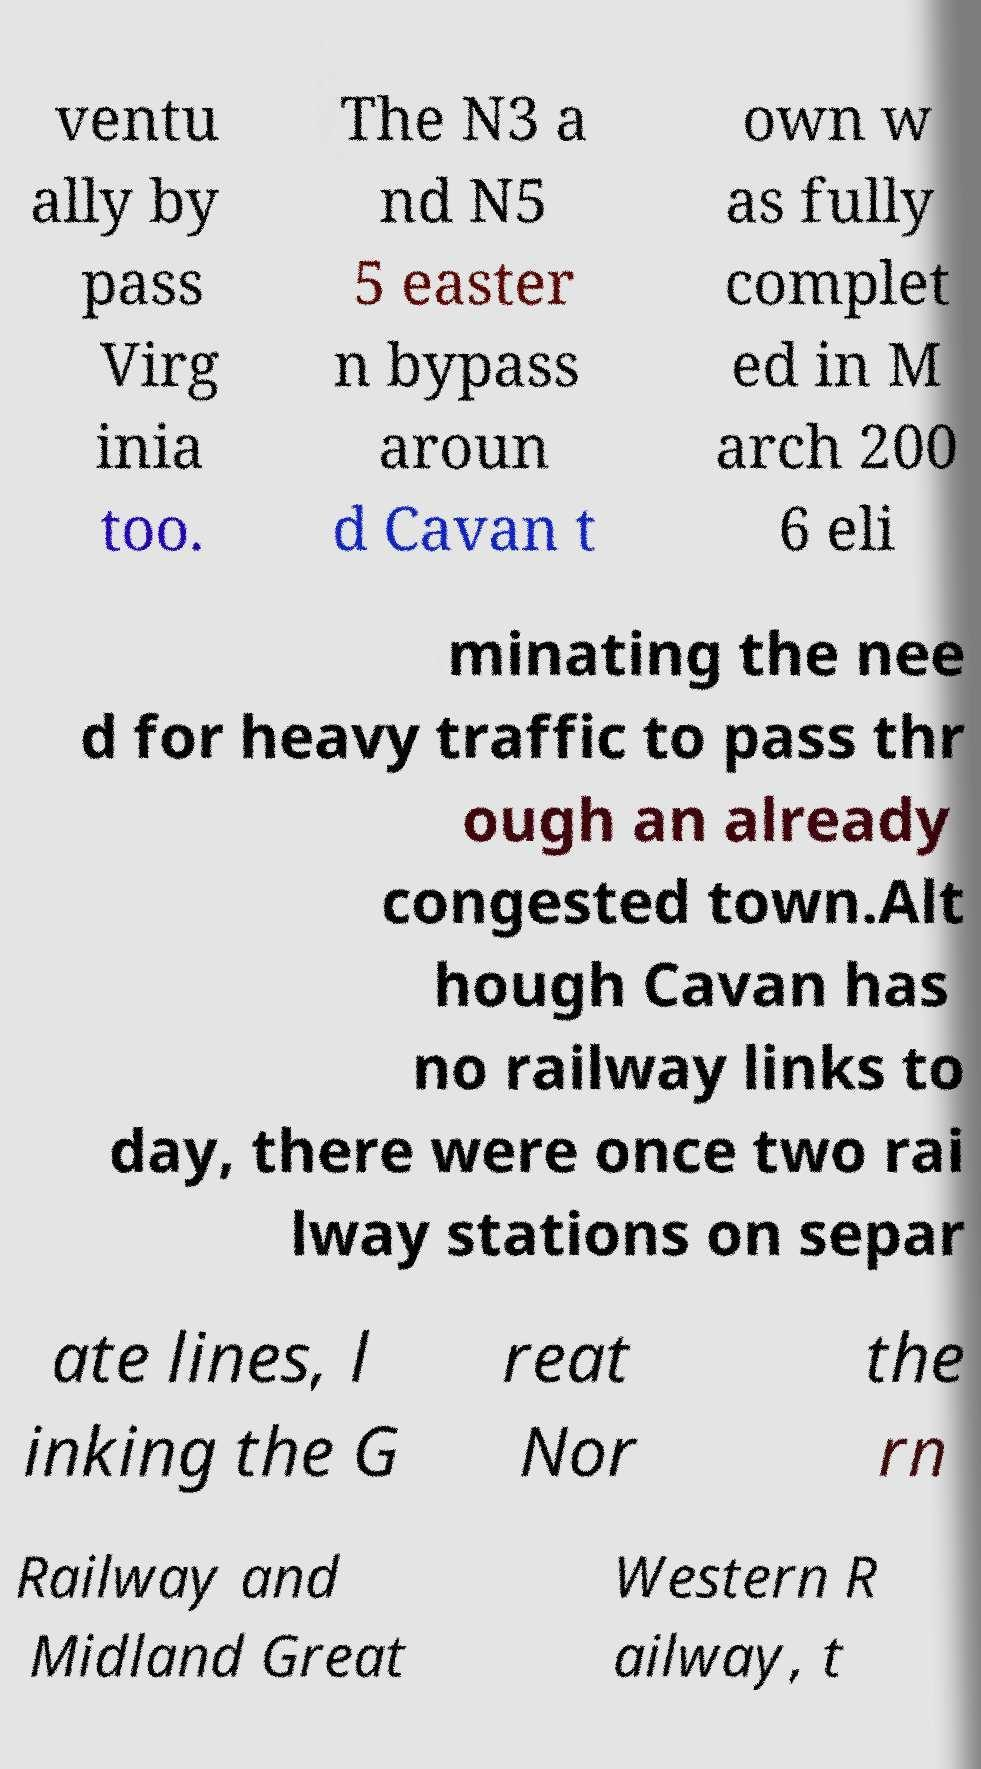There's text embedded in this image that I need extracted. Can you transcribe it verbatim? ventu ally by pass Virg inia too. The N3 a nd N5 5 easter n bypass aroun d Cavan t own w as fully complet ed in M arch 200 6 eli minating the nee d for heavy traffic to pass thr ough an already congested town.Alt hough Cavan has no railway links to day, there were once two rai lway stations on separ ate lines, l inking the G reat Nor the rn Railway and Midland Great Western R ailway, t 